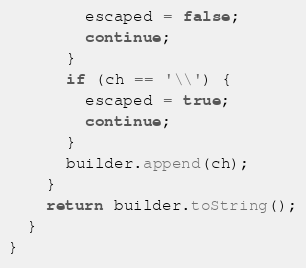<code> <loc_0><loc_0><loc_500><loc_500><_Java_>        escaped = false;
        continue;
      }
      if (ch == '\\') {
        escaped = true;
        continue;
      }
      builder.append(ch);
    }
    return builder.toString();
  }
}</code> 